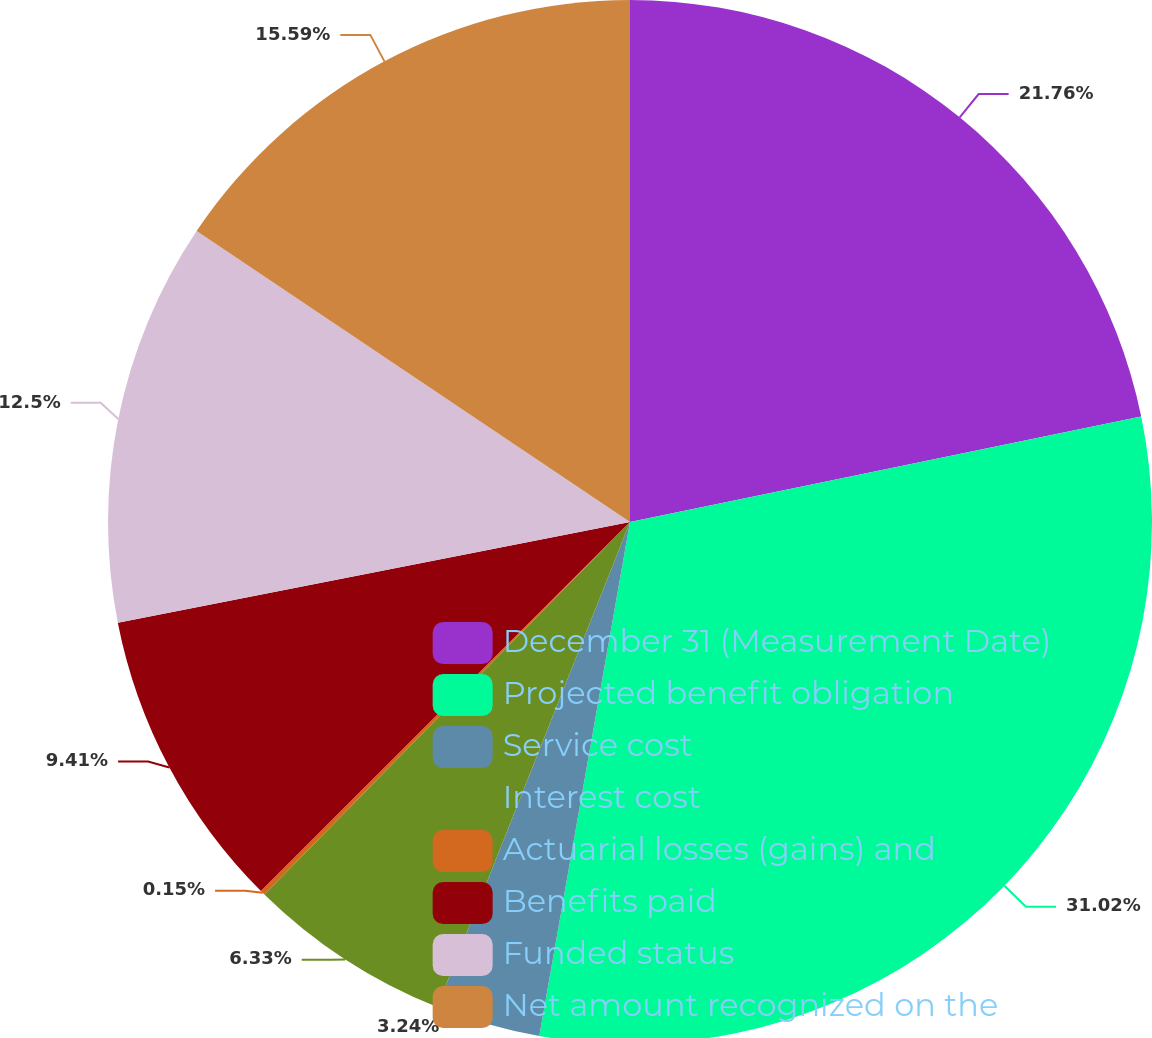<chart> <loc_0><loc_0><loc_500><loc_500><pie_chart><fcel>December 31 (Measurement Date)<fcel>Projected benefit obligation<fcel>Service cost<fcel>Interest cost<fcel>Actuarial losses (gains) and<fcel>Benefits paid<fcel>Funded status<fcel>Net amount recognized on the<nl><fcel>21.76%<fcel>31.02%<fcel>3.24%<fcel>6.33%<fcel>0.15%<fcel>9.41%<fcel>12.5%<fcel>15.59%<nl></chart> 